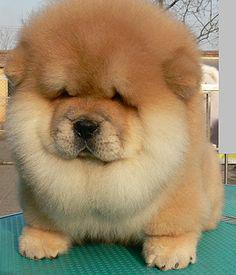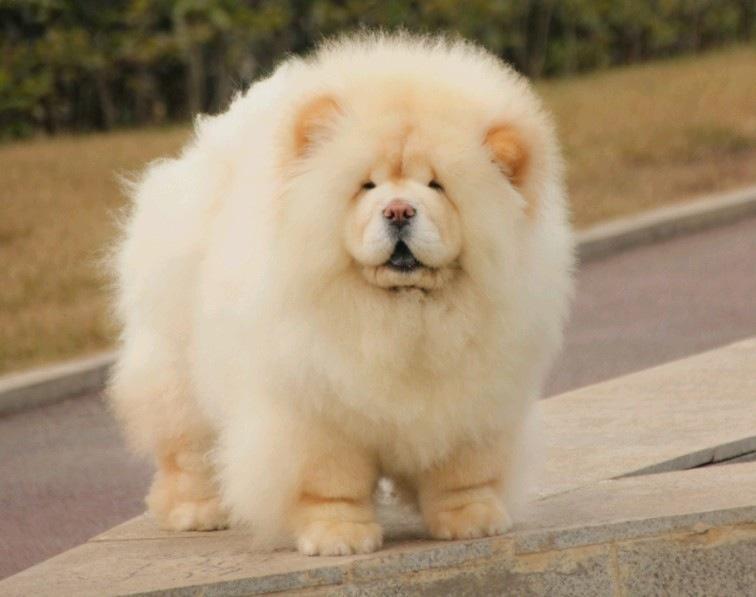The first image is the image on the left, the second image is the image on the right. For the images displayed, is the sentence "A chow with orange-tinged fur is posed on a greenish surface in at least one image." factually correct? Answer yes or no. Yes. The first image is the image on the left, the second image is the image on the right. Analyze the images presented: Is the assertion "The dogs are standing outside, but not on the grass." valid? Answer yes or no. Yes. 